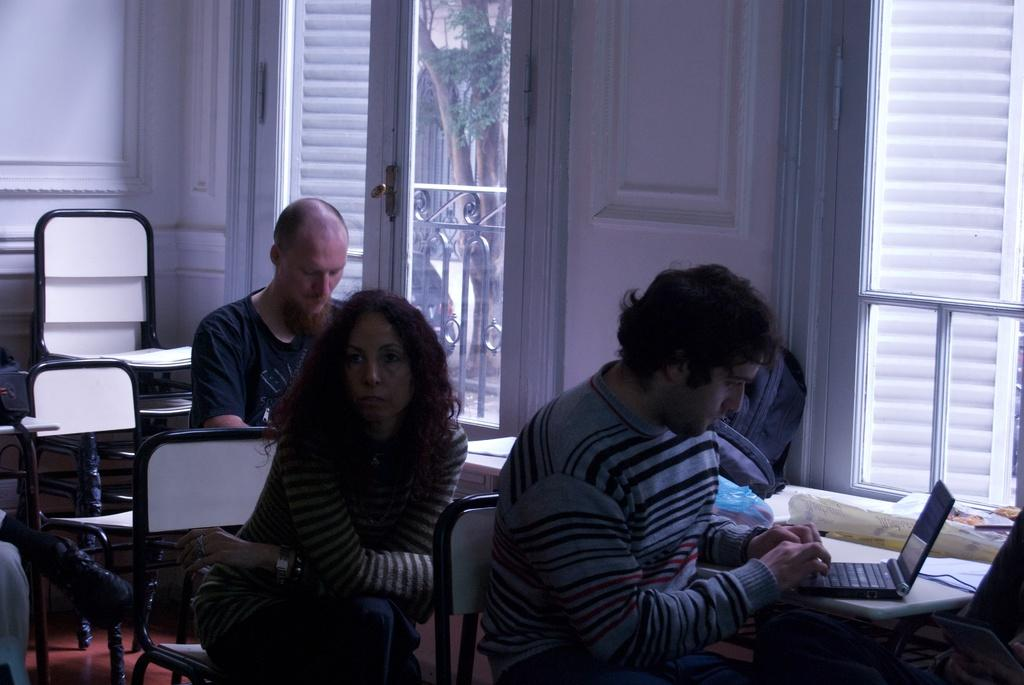How many people are sitting in the image? There are three persons sitting on chairs in the image. What can be seen through the window in the image? A fence and a tree are visible through the window in the image. What is the man doing in the image? The man is working on a laptop in the image. What object is present on the table in the image? There is a bag on the table in the image. What type of frog can be seen participating in the protest in the image? There is no frog or protest present in the image. What word is written on the bag on the table in the image? The provided facts do not mention any specific words on the bag, so we cannot determine what word is written on it. 